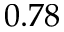<formula> <loc_0><loc_0><loc_500><loc_500>0 . 7 8</formula> 